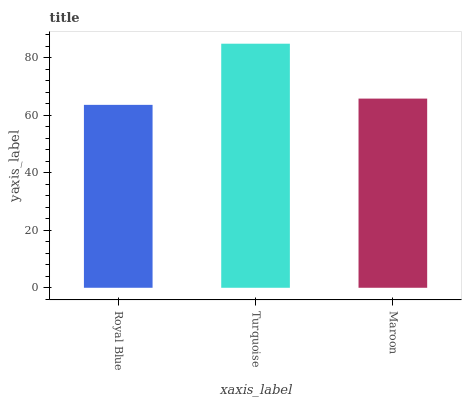Is Royal Blue the minimum?
Answer yes or no. Yes. Is Turquoise the maximum?
Answer yes or no. Yes. Is Maroon the minimum?
Answer yes or no. No. Is Maroon the maximum?
Answer yes or no. No. Is Turquoise greater than Maroon?
Answer yes or no. Yes. Is Maroon less than Turquoise?
Answer yes or no. Yes. Is Maroon greater than Turquoise?
Answer yes or no. No. Is Turquoise less than Maroon?
Answer yes or no. No. Is Maroon the high median?
Answer yes or no. Yes. Is Maroon the low median?
Answer yes or no. Yes. Is Royal Blue the high median?
Answer yes or no. No. Is Royal Blue the low median?
Answer yes or no. No. 